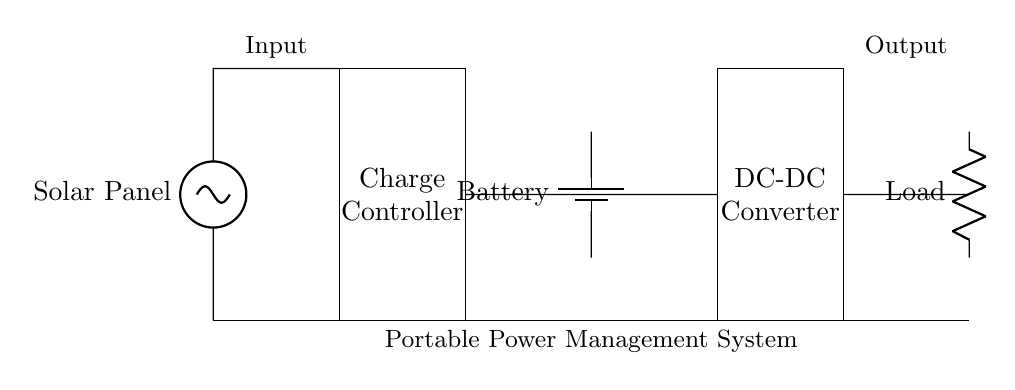What is the primary energy source in this system? The primary energy source is depicted by the solar panel at the left of the diagram, which collects solar energy and converts it into electrical energy.
Answer: Solar Panel What component regulates the charging process? The charge controller is the rectangular component at the center of the circuit, which manages the flow of electricity from the solar panel to the battery, ensuring proper charging and preventing overload.
Answer: Charge Controller What type of load is represented in this circuit? The load is represented by a resistor in the circuit diagram, indicating that it consumes electrical energy from the system, typically representing devices powered by the system.
Answer: Resistor How many energy storage components are in the circuit? There is one battery in the circuit, shown as a vertical cylinder, which stores the electrical energy generated by the solar panel for later use.
Answer: One Which component converts the battery output to a different voltage? The DC-DC converter, shown as a rectangle on the right side of the charge controller, converts the battery voltage to a level suitable for the connected load.
Answer: DC-DC Converter What is the purpose of the connections marked with shorts? The shorts represent conductive paths that connect the various components, allowing the flow of electricity from the solar panel through the charge controller, battery, and to the load, completing the electrical circuit.
Answer: Conductive Paths What direction does the power flow in this circuit? Power flows from the left (solar panel) to the right (load), passing through the charge controller and battery, clearly indicated by the connections between each component moving in that direction.
Answer: Left to Right 